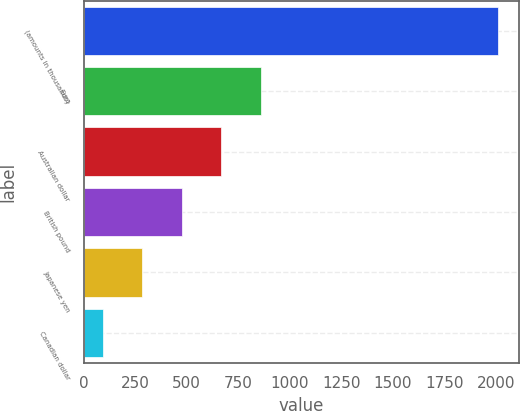Convert chart to OTSL. <chart><loc_0><loc_0><loc_500><loc_500><bar_chart><fcel>(amounts in thousands)<fcel>Euro<fcel>Australian dollar<fcel>British pound<fcel>Japanese yen<fcel>Canadian dollar<nl><fcel>2012<fcel>860.6<fcel>668.7<fcel>476.8<fcel>284.9<fcel>93<nl></chart> 